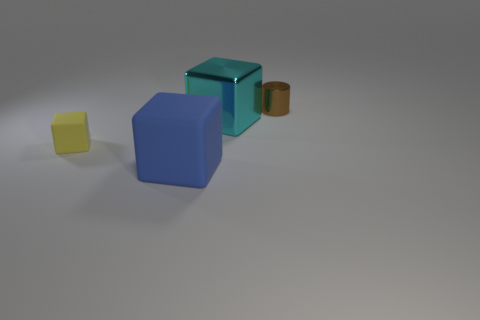Add 3 small rubber things. How many objects exist? 7 Subtract all green blocks. Subtract all red spheres. How many blocks are left? 3 Subtract all cylinders. How many objects are left? 3 Subtract all cyan shiny things. Subtract all small blocks. How many objects are left? 2 Add 2 big rubber objects. How many big rubber objects are left? 3 Add 1 brown metal things. How many brown metal things exist? 2 Subtract 0 red cylinders. How many objects are left? 4 